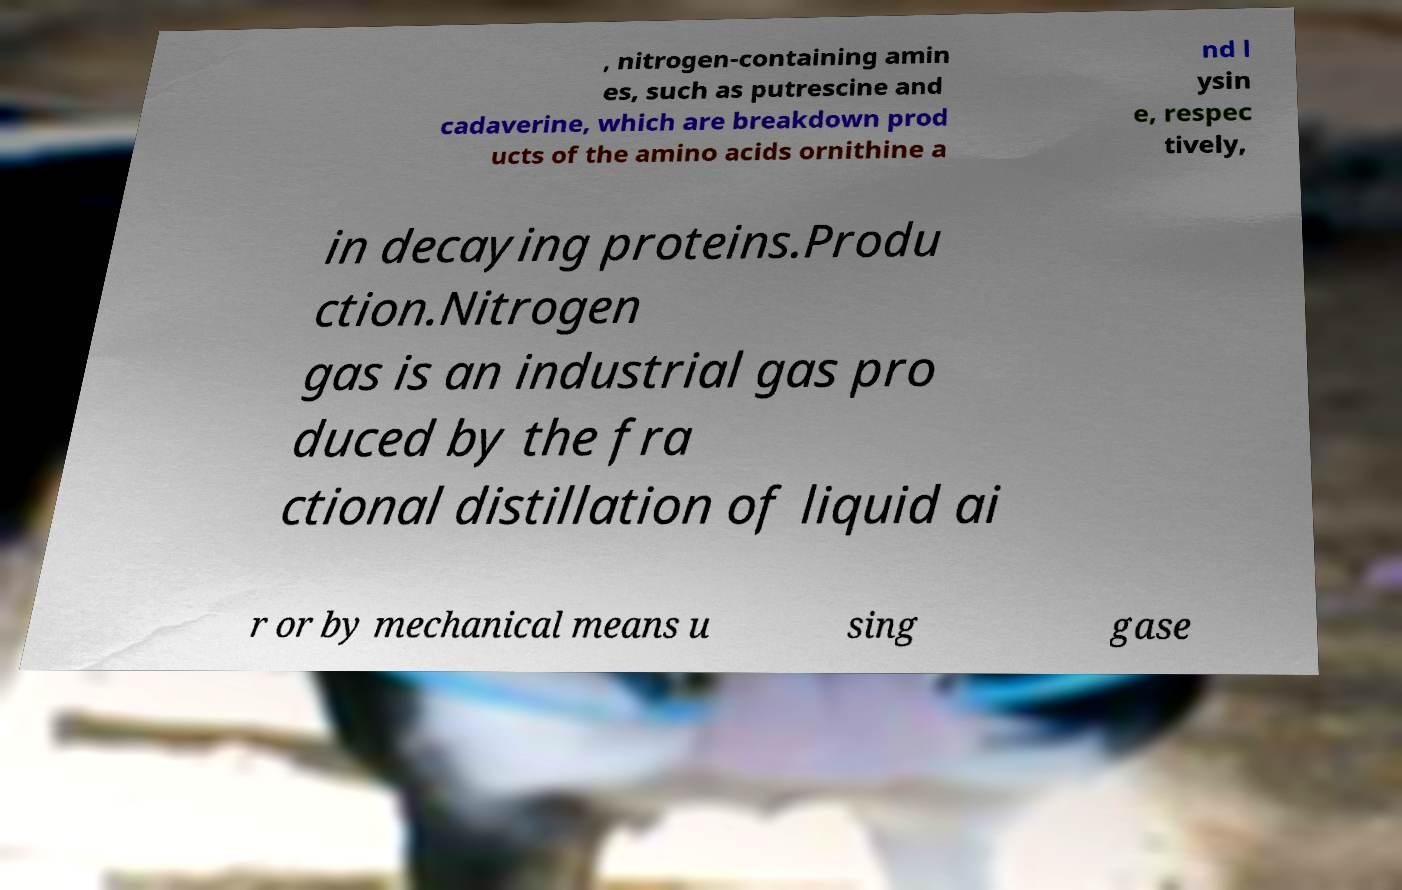Could you extract and type out the text from this image? , nitrogen-containing amin es, such as putrescine and cadaverine, which are breakdown prod ucts of the amino acids ornithine a nd l ysin e, respec tively, in decaying proteins.Produ ction.Nitrogen gas is an industrial gas pro duced by the fra ctional distillation of liquid ai r or by mechanical means u sing gase 